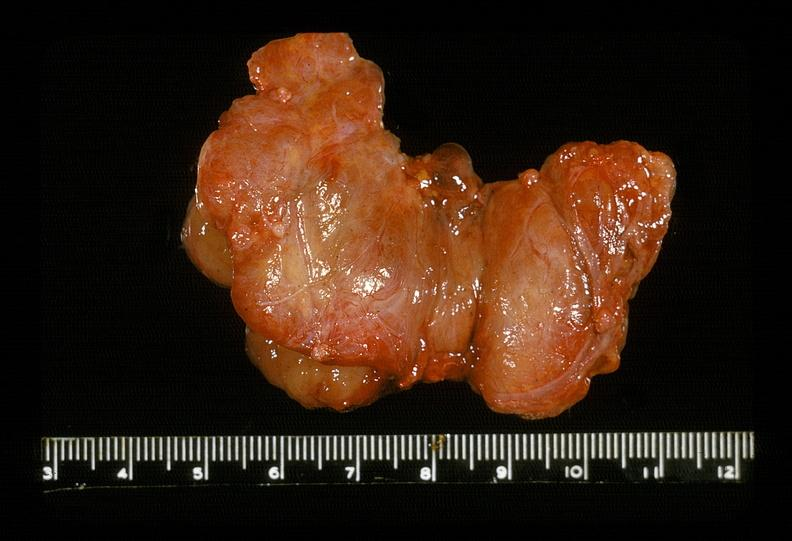what does this image show?
Answer the question using a single word or phrase. Thyroid 